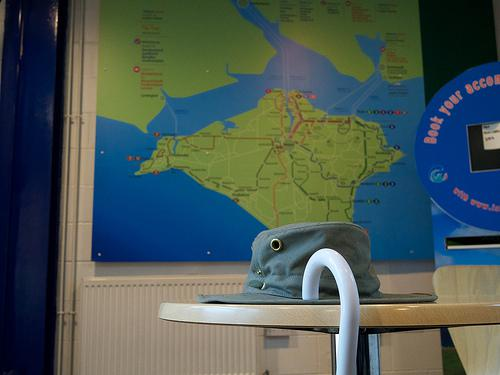Question: why was the picture taken?
Choices:
A. To show a painting.
B. To show a sign.
C. To show a menu.
D. To show a map.
Answer with the letter. Answer: D Question: where is the map in the picture?
Choices:
A. On the table.
B. On a wall.
C. On the desk.
D. Behind the chairs.
Answer with the letter. Answer: B Question: what is the map hanging from?
Choices:
A. A string.
B. Wall hooks.
C. A wall.
D. A whiteboard.
Answer with the letter. Answer: C Question: what is the white stick on the table?
Choices:
A. A pen.
B. A pencil.
C. A candy cane.
D. A cane.
Answer with the letter. Answer: D Question: who is standing by the map?
Choices:
A. A man.
B. A woman.
C. No one.
D. A child.
Answer with the letter. Answer: C Question: how many pictures of maps are on the wall?
Choices:
A. Five.
B. Two.
C. Three.
D. One.
Answer with the letter. Answer: D 